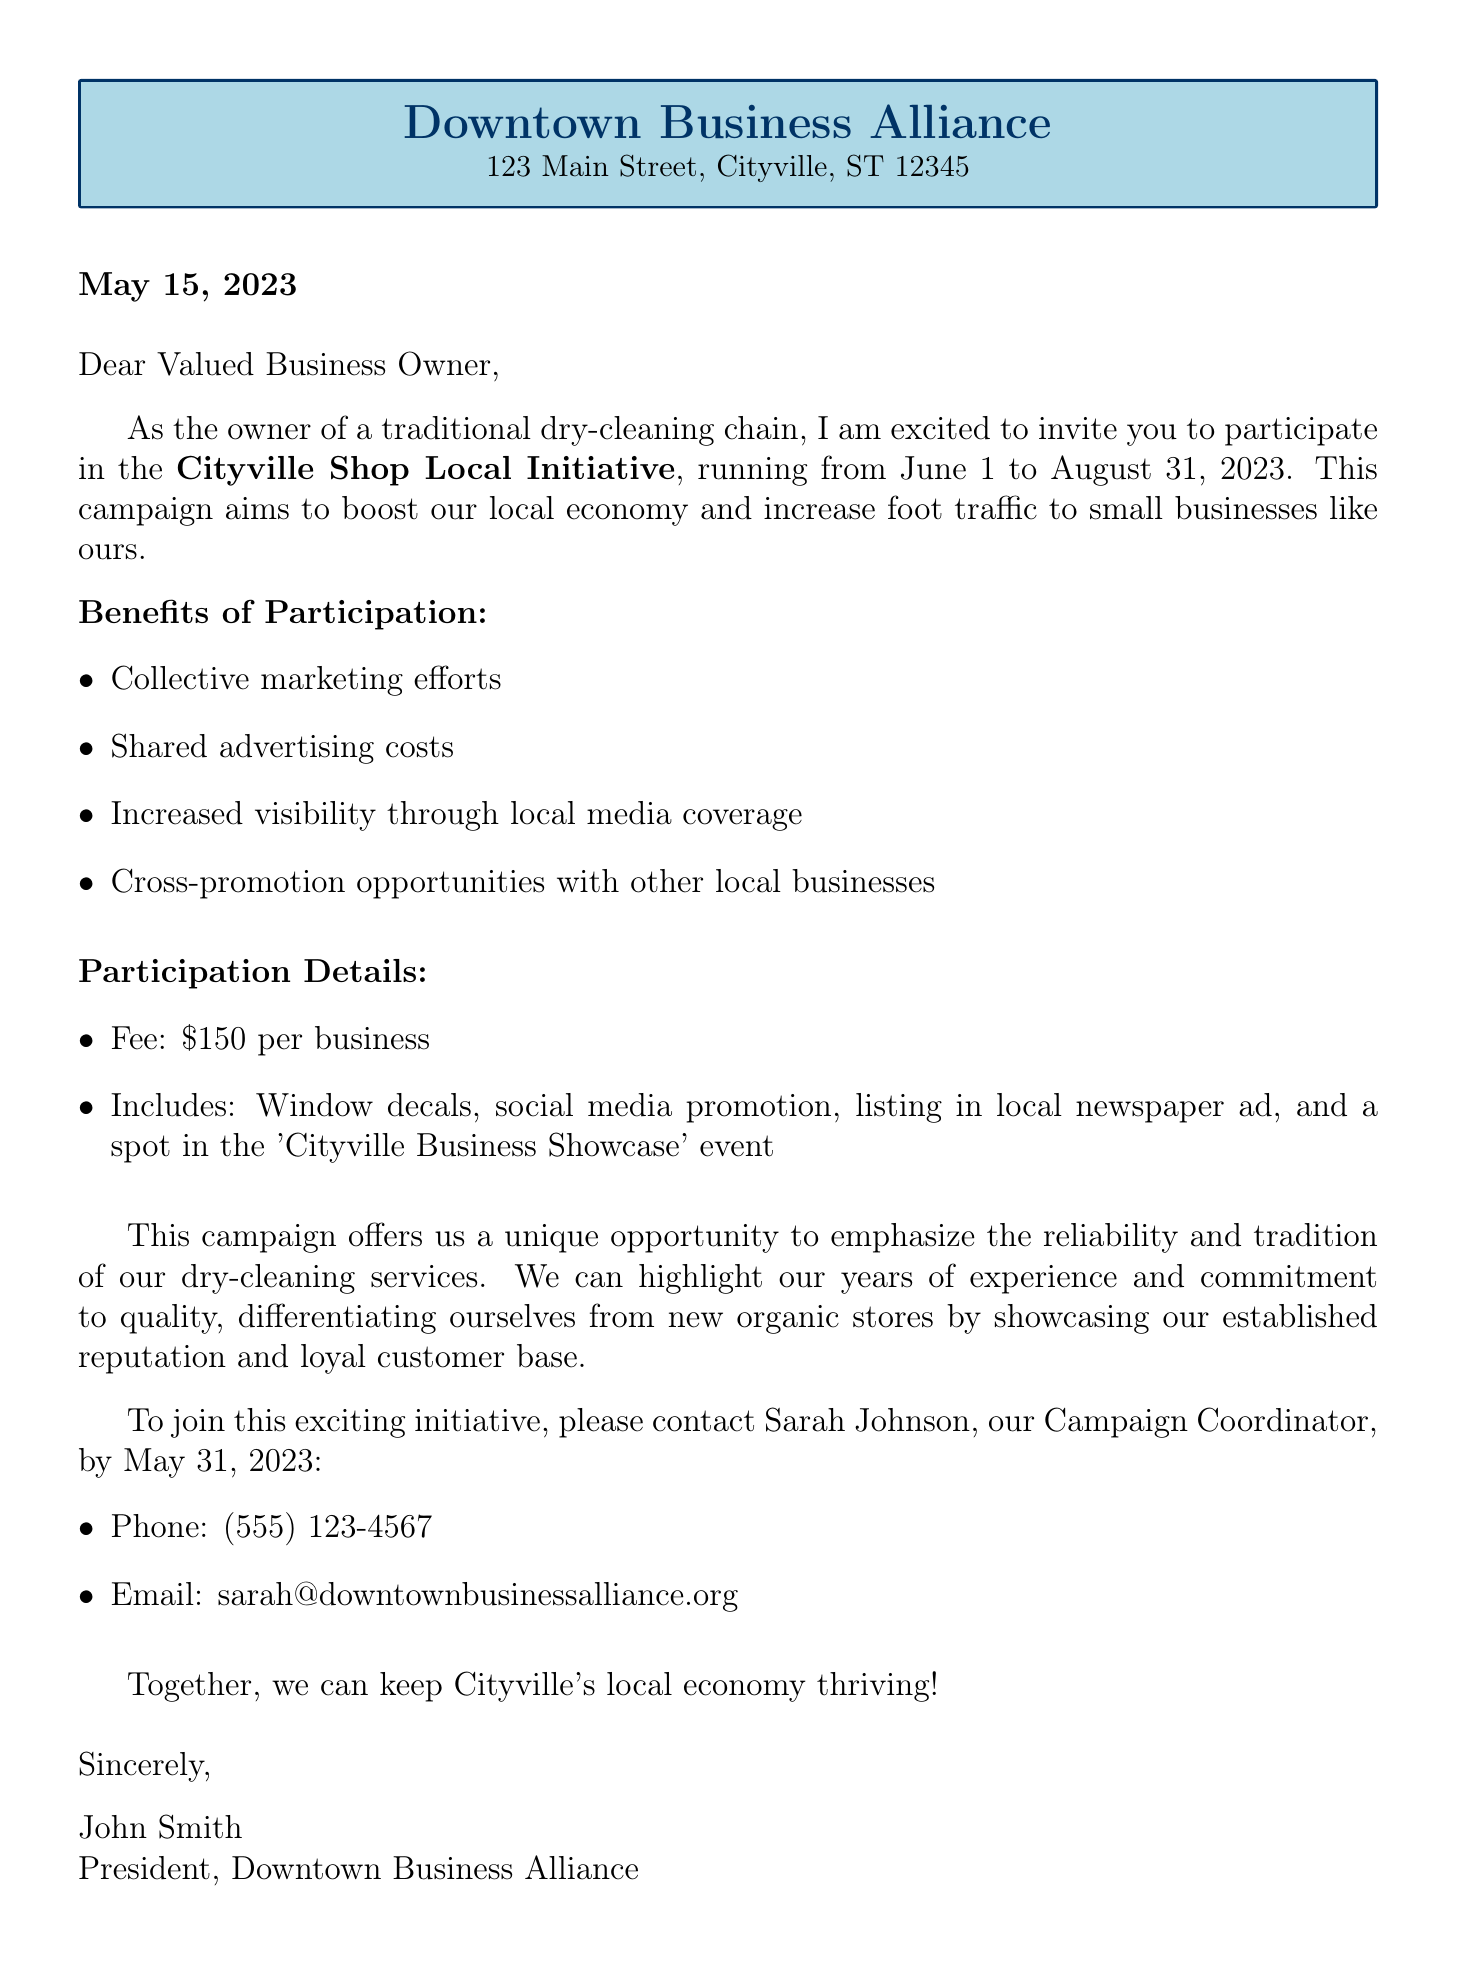What is the name of the campaign? The campaign is referred to as the "Cityville Shop Local Initiative" in the document.
Answer: Cityville Shop Local Initiative What are the dates of the campaign? The document states that the campaign runs from June 1 to August 31, 2023.
Answer: June 1 - August 31, 2023 What is the participation fee for each business? The document mentions that the fee for participation is $150 per business.
Answer: $150 Who should be contacted for more information? The contact person named in the document is Sarah Johnson, the Campaign Coordinator.
Answer: Sarah Johnson What is one of the benefits of participating in the campaign? The document lists several benefits; one is "Collective marketing efforts."
Answer: Collective marketing efforts How does the campaign help differentiate from organic stores? The document states that it highlights "established reputation and loyal customer base" as a competitive edge.
Answer: Established reputation and loyal customer base What is the deadline to join the campaign? According to the document, the deadline to participate is May 31, 2023.
Answer: May 31, 2023 What is the closing statement of the letter? The closing statement encourages collaboration to maintain the local economy, referring to keeping Cityville's local economy thriving.
Answer: Together, we can keep Cityville's local economy thriving! 